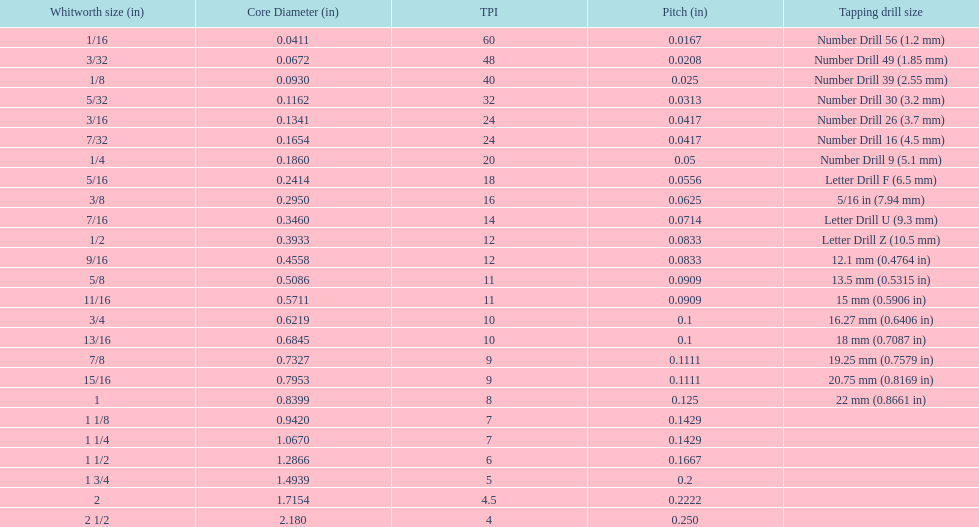What core diameter (in) comes after 0.0930? 0.1162. 